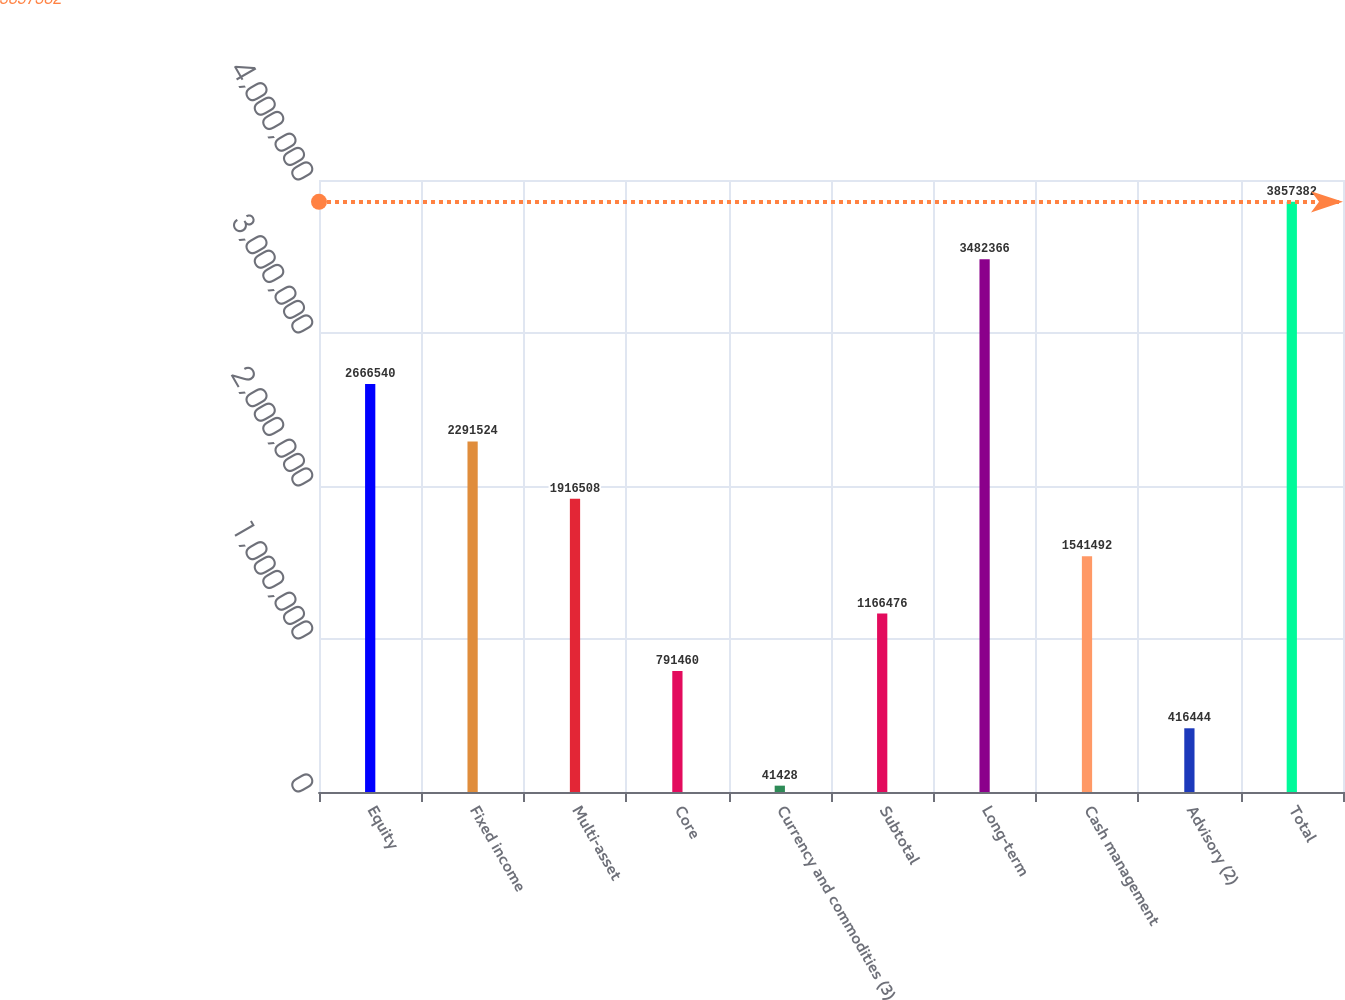<chart> <loc_0><loc_0><loc_500><loc_500><bar_chart><fcel>Equity<fcel>Fixed income<fcel>Multi-asset<fcel>Core<fcel>Currency and commodities (3)<fcel>Subtotal<fcel>Long-term<fcel>Cash management<fcel>Advisory (2)<fcel>Total<nl><fcel>2.66654e+06<fcel>2.29152e+06<fcel>1.91651e+06<fcel>791460<fcel>41428<fcel>1.16648e+06<fcel>3.48237e+06<fcel>1.54149e+06<fcel>416444<fcel>3.85738e+06<nl></chart> 